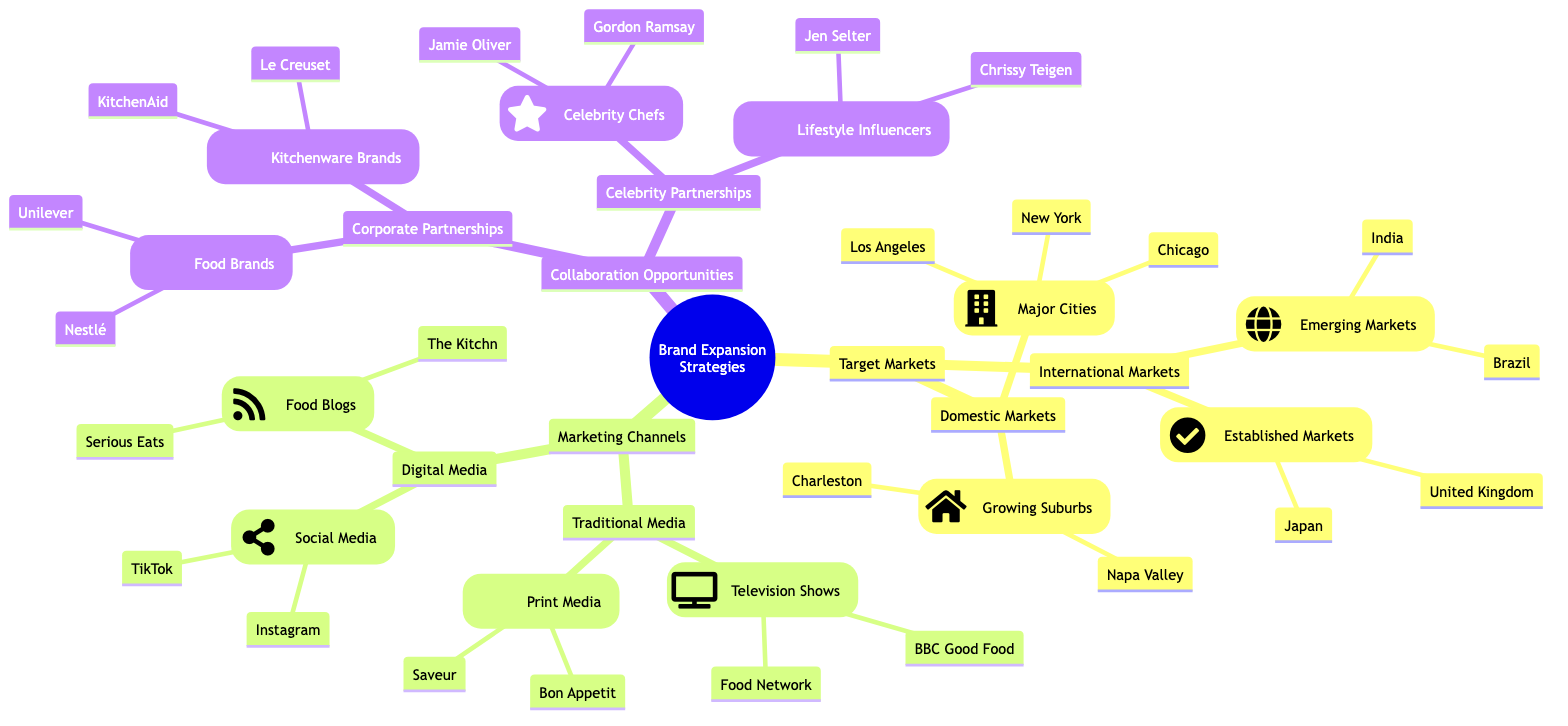What are the two major domestic markets listed? The diagram lists "Major Cities" and "Growing Suburbs" under "Domestic Markets." The major cities mentioned are New York, Los Angeles, and Chicago.
Answer: Major Cities: New York, Los Angeles, Chicago How many international markets are identified? The diagram under "International Markets" outlines two categories: "Emerging Markets" and "Established Markets." Each category contains an equal number of markets, so there are a total of four international markets mentioned: Brazil, India, the United Kingdom, and Japan.
Answer: 4 Which marketing channel includes television shows? "Traditional Media" is the category where "Television Shows" are mentioned. It specifically includes Food Network and BBC Good Food.
Answer: Traditional Media Name one food blog listed under digital media. The diagram includes "Serious Eats" and "The Kitchn" under the "Food Blogs" section in "Digital Media." You can mention either one as both are valid answers.
Answer: Serious Eats How many types of corporate partnerships are mentioned? Under "Collaboration Opportunities," the section on "Corporate Partnerships" includes "Food Brands" and "Kitchenware Brands." This indicates there are two distinct types of corporate partnerships listed.
Answer: 2 What is a celebrity chef mentioned in the collaboration opportunities? Within "Celebrity Partnerships," "Gordon Ramsay" and "Jamie Oliver" are both highlighted as celebrity chefs. You can choose either name as a valid response.
Answer: Gordon Ramsay What are the two platforms listed under social media? The diagram specifies "Instagram" and "TikTok" as platforms under the "Social Media" category in "Digital Media."
Answer: Instagram, TikTok Which established market is listed as a target market? Among the "Established Markets," "United Kingdom" and "Japan" are both included, either can represent a valid answer to the question regarding established markets.
Answer: United Kingdom How many items are categorized under "Growing Suburbs"? The diagram outlines two locations under "Growing Suburbs": Napa Valley and Charleston. This means there are two items listed in this specific category.
Answer: 2 